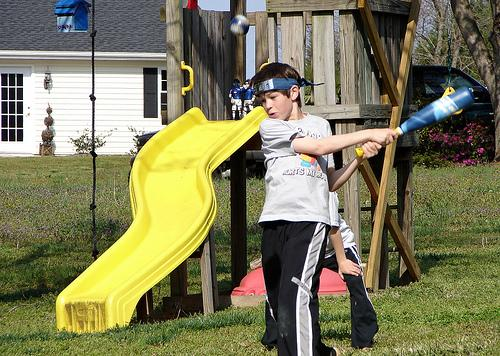What is the primary activity that the boy is engaged in? The boy is swinging a baseball bat. Describe the boy's clothes with specific colors mentioned. The boy is wearing a white, blue, yellow, and orange shirt, and black and white jogging pants. Identify an object in the top-left corner of the image that has to do with the entrance of a house. A decorative tree by the door. Please provide a brief description of the house and its features. The white house has a decorative tree by the door, the door has fifteen windows, and the rooftop is visible. Which object has knots in it, and what is its main color? A black rope has knots in it. Explain what the baseball and bat look like in the image. The baseball is blue and gray, while the bat is blue, white, and yellow with a yellow handle. What type of play equipment is featured in the image? A wooden fort with a slide and a rope for climbing. How many objects are on top of the slide, and what are they? There are two toys sitting on top of the slide. In one sentence, describe the main object and its distinguishing features. A boy swinging a baseball bat, wearing a blue headband, a colorful t-shirt, and black and gray pants. Name the color and main features of the slide in the image. The slide is yellow and appears to be a slipper slide. 